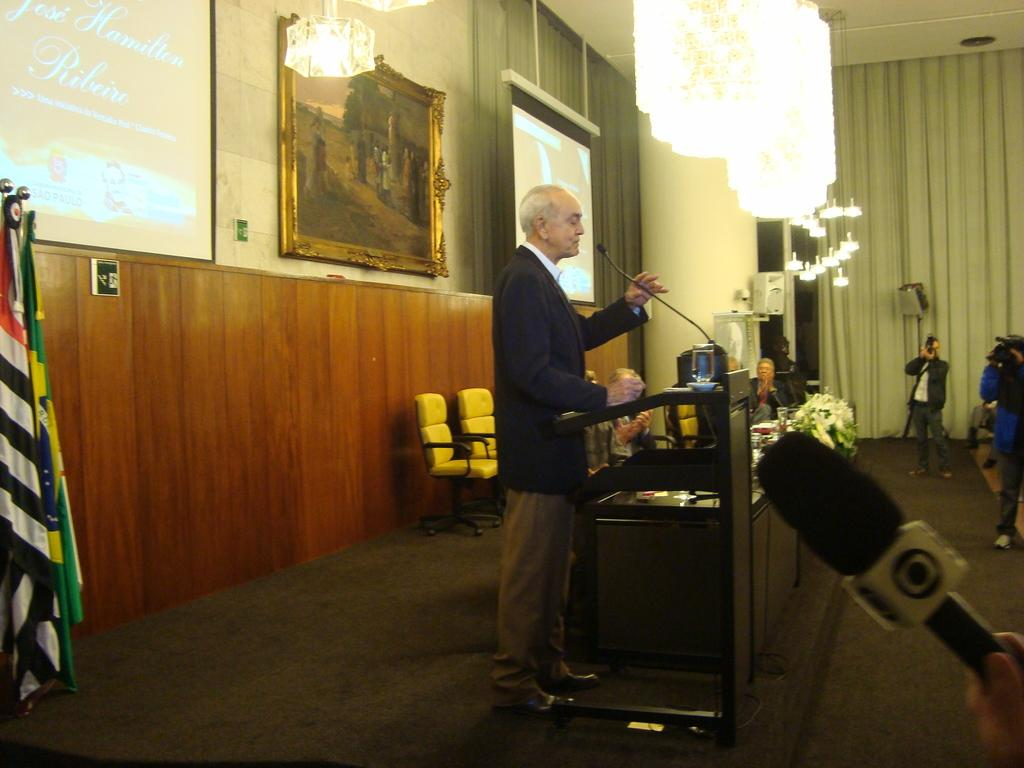What type of structure can be seen in the image? There is a wall in the image. Are there any decorative items on the wall? Yes, there is a photo frame in the image. What type of electronic devices are present in the image? There are screens and lights in the image. What type of symbolic items can be seen in the image? There are flags in the image. What type of furniture is present in the image? There are tables in the image. Are there any people in the image? Yes, there are people in the image. What type of equipment is used for amplifying sound in the image? There are microphones (mics) in the image. What type of device is used for capturing images in the image? There is a camera in the image. What type of window treatment is present in the image? There are curtains in the image. What type of knife is being used to stir the stew in the image? There is no knife or stew present in the image. What type of powder is being sprinkled on the curtains in the image? There is no powder or action of sprinkling on the curtains in the image. 